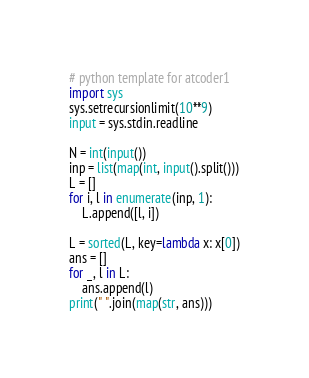Convert code to text. <code><loc_0><loc_0><loc_500><loc_500><_Python_># python template for atcoder1
import sys
sys.setrecursionlimit(10**9)
input = sys.stdin.readline

N = int(input())
inp = list(map(int, input().split()))
L = []
for i, l in enumerate(inp, 1):
    L.append([l, i])

L = sorted(L, key=lambda x: x[0])
ans = []
for _, l in L:
    ans.append(l)
print(" ".join(map(str, ans)))
</code> 